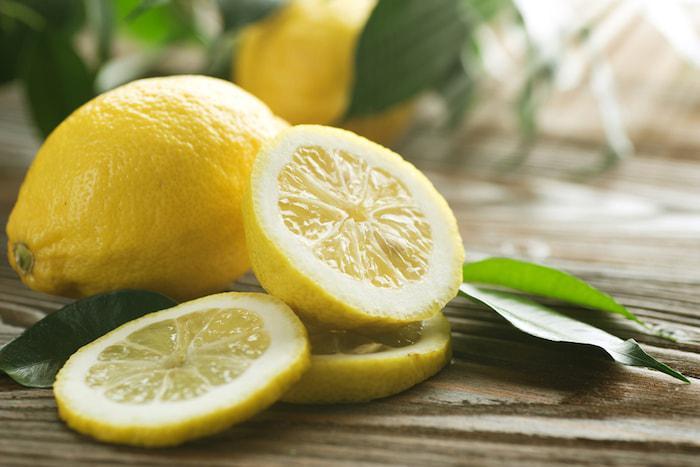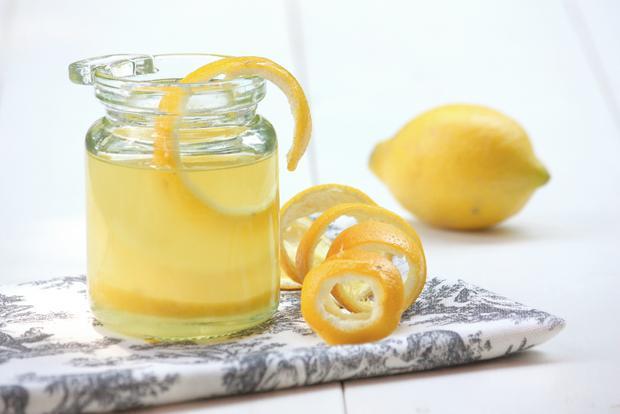The first image is the image on the left, the second image is the image on the right. Analyze the images presented: Is the assertion "There are two whole lemons and three lemon halves." valid? Answer yes or no. No. The first image is the image on the left, the second image is the image on the right. Analyze the images presented: Is the assertion "The left and right image contains a total of the same full lemons and lemon slices." valid? Answer yes or no. No. 